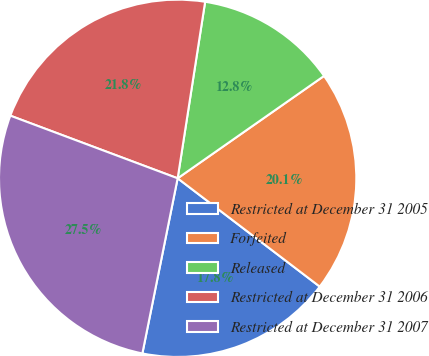Convert chart. <chart><loc_0><loc_0><loc_500><loc_500><pie_chart><fcel>Restricted at December 31 2005<fcel>Forfeited<fcel>Released<fcel>Restricted at December 31 2006<fcel>Restricted at December 31 2007<nl><fcel>17.8%<fcel>20.08%<fcel>12.83%<fcel>21.76%<fcel>27.54%<nl></chart> 